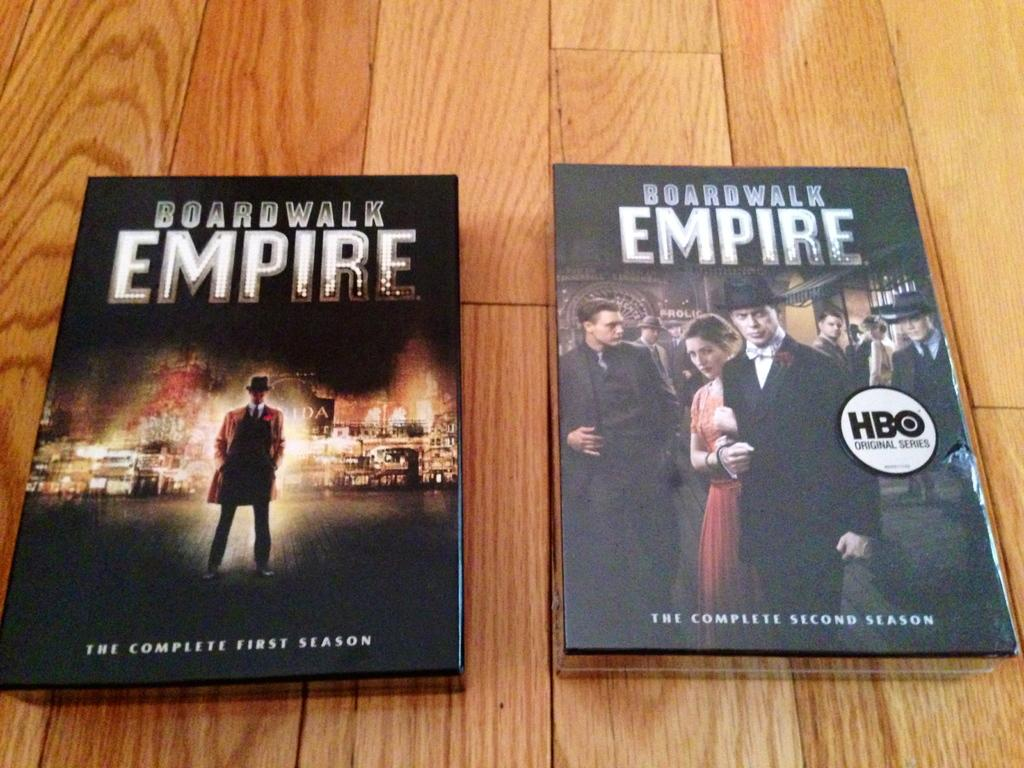Provide a one-sentence caption for the provided image. Case for Boardwalk Empire laying on the floor. 